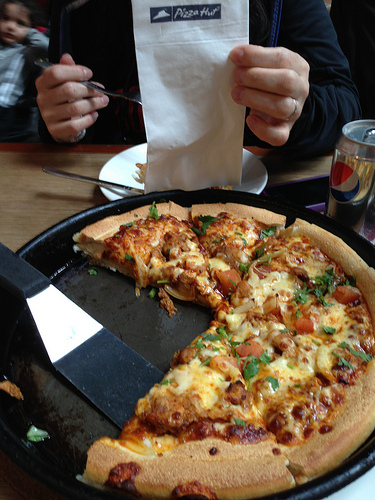Please provide the bounding box coordinate of the region this sentence describes: Silverware resting on a white plate. The silverware resting on a white plate can be found at the coordinates approximately [0.2, 0.28, 0.66, 0.4]. 